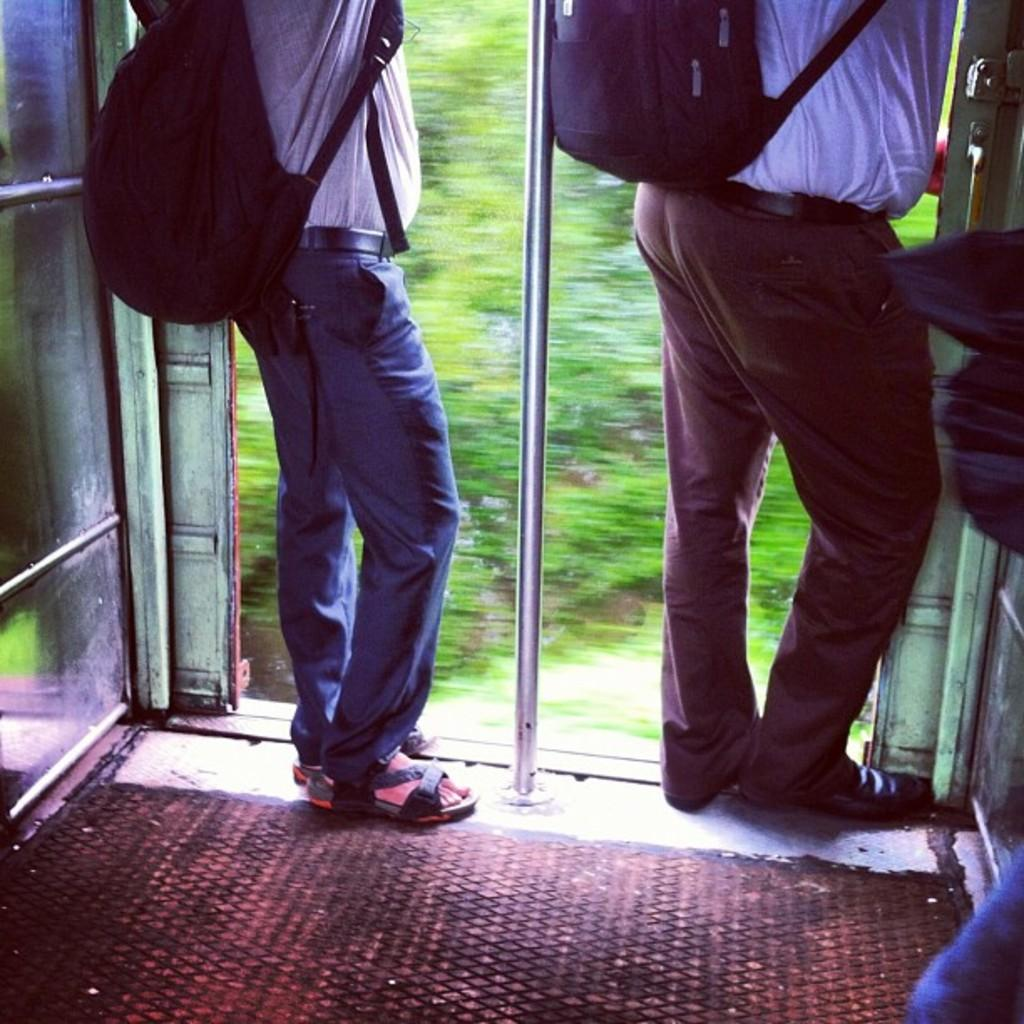What type of setting is depicted in the image? The image shows an inside view of a train. How many people are present in the image? There are two persons in the image. What are the persons wearing? The persons are wearing clothes. What are the persons carrying in the image? The persons are carrying bags. What can be seen in the middle of the image? There is a pole in the middle of the image. What type of punishment is being administered to the kitten in the image? There is no kitten present in the image, and therefore no punishment is being administered. What type of business is being conducted in the image? The image does not depict any business activities; it shows an inside view of a train with two persons carrying bags. 